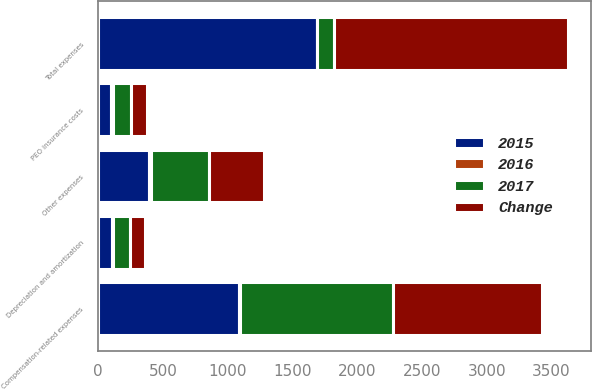Convert chart to OTSL. <chart><loc_0><loc_0><loc_500><loc_500><stacked_bar_chart><ecel><fcel>Compensation-related expenses<fcel>Depreciation and amortization<fcel>PEO insurance costs<fcel>Other expenses<fcel>Total expenses<nl><fcel>2017<fcel>1188.5<fcel>126.9<fcel>142.2<fcel>454.1<fcel>126.9<nl><fcel>2016<fcel>4<fcel>10<fcel>17<fcel>8<fcel>6<nl><fcel>Change<fcel>1148.2<fcel>115.1<fcel>122<fcel>420<fcel>1805.3<nl><fcel>2015<fcel>1087.1<fcel>106.6<fcel>96.2<fcel>396.1<fcel>1686<nl></chart> 